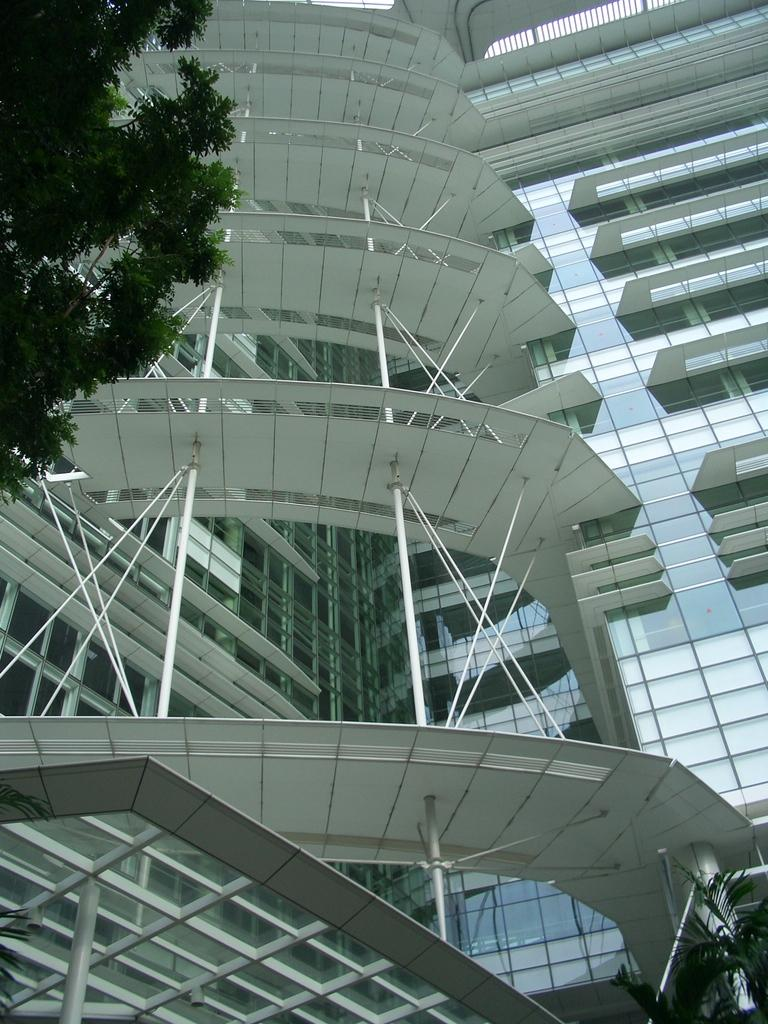What is the main subject of the image? The main subject of the image is the outside view of a building. Are there any natural elements visible in the image? Yes, there are trees visible in the image. What type of noise can be heard coming from the store in the image? There is no store present in the image, so it's not possible to determine what, if any, noise might be heard. 